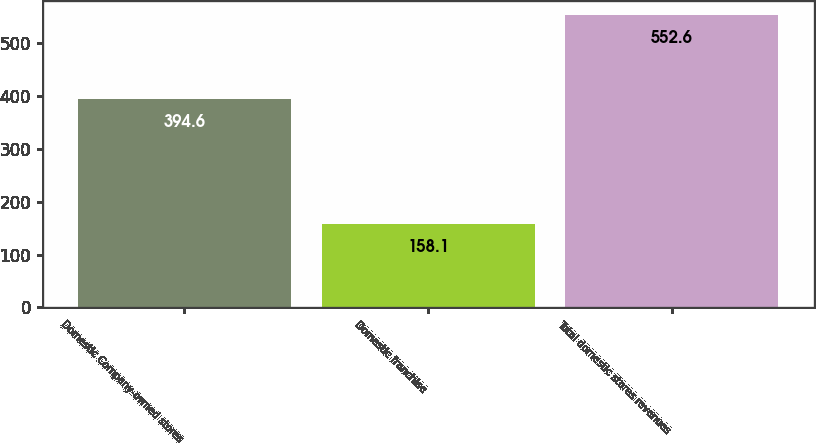Convert chart. <chart><loc_0><loc_0><loc_500><loc_500><bar_chart><fcel>Domestic Company-owned stores<fcel>Domestic franchise<fcel>Total domestic stores revenues<nl><fcel>394.6<fcel>158.1<fcel>552.6<nl></chart> 